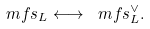<formula> <loc_0><loc_0><loc_500><loc_500>\ m f s _ { L } \longleftrightarrow \ m f s _ { L } ^ { \vee } .</formula> 